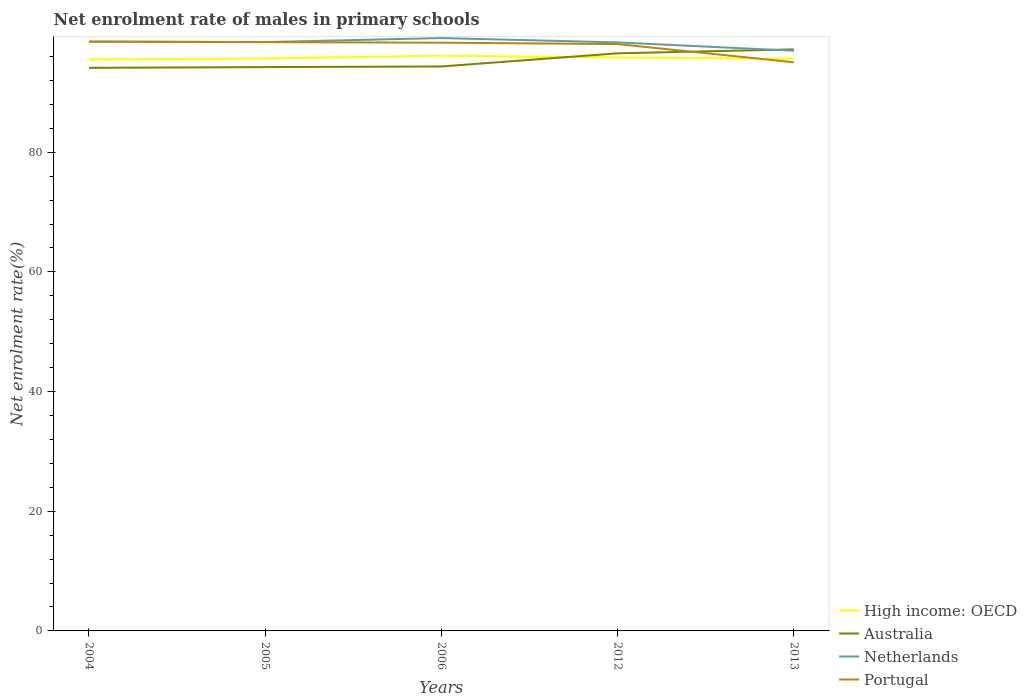How many different coloured lines are there?
Your answer should be very brief. 4. Is the number of lines equal to the number of legend labels?
Your answer should be very brief. Yes. Across all years, what is the maximum net enrolment rate of males in primary schools in High income: OECD?
Make the answer very short. 95.5. In which year was the net enrolment rate of males in primary schools in Australia maximum?
Make the answer very short. 2004. What is the total net enrolment rate of males in primary schools in High income: OECD in the graph?
Offer a terse response. 0.54. What is the difference between the highest and the second highest net enrolment rate of males in primary schools in Portugal?
Keep it short and to the point. 3.47. Is the net enrolment rate of males in primary schools in High income: OECD strictly greater than the net enrolment rate of males in primary schools in Australia over the years?
Give a very brief answer. No. How many years are there in the graph?
Keep it short and to the point. 5. How many legend labels are there?
Your answer should be compact. 4. How are the legend labels stacked?
Give a very brief answer. Vertical. What is the title of the graph?
Offer a very short reply. Net enrolment rate of males in primary schools. What is the label or title of the Y-axis?
Provide a short and direct response. Net enrolment rate(%). What is the Net enrolment rate(%) of High income: OECD in 2004?
Keep it short and to the point. 95.5. What is the Net enrolment rate(%) in Australia in 2004?
Your answer should be very brief. 94.11. What is the Net enrolment rate(%) of Netherlands in 2004?
Provide a succinct answer. 98.47. What is the Net enrolment rate(%) of Portugal in 2004?
Give a very brief answer. 98.51. What is the Net enrolment rate(%) in High income: OECD in 2005?
Ensure brevity in your answer.  95.67. What is the Net enrolment rate(%) in Australia in 2005?
Ensure brevity in your answer.  94.23. What is the Net enrolment rate(%) in Netherlands in 2005?
Ensure brevity in your answer.  98.41. What is the Net enrolment rate(%) of Portugal in 2005?
Offer a very short reply. 98.4. What is the Net enrolment rate(%) of High income: OECD in 2006?
Your response must be concise. 96.13. What is the Net enrolment rate(%) of Australia in 2006?
Offer a terse response. 94.33. What is the Net enrolment rate(%) of Netherlands in 2006?
Make the answer very short. 99.08. What is the Net enrolment rate(%) of Portugal in 2006?
Ensure brevity in your answer.  98.3. What is the Net enrolment rate(%) of High income: OECD in 2012?
Provide a short and direct response. 95.85. What is the Net enrolment rate(%) in Australia in 2012?
Your response must be concise. 96.53. What is the Net enrolment rate(%) in Netherlands in 2012?
Keep it short and to the point. 98.36. What is the Net enrolment rate(%) of Portugal in 2012?
Your answer should be compact. 98.07. What is the Net enrolment rate(%) of High income: OECD in 2013?
Offer a terse response. 95.6. What is the Net enrolment rate(%) of Australia in 2013?
Ensure brevity in your answer.  97.19. What is the Net enrolment rate(%) in Netherlands in 2013?
Your response must be concise. 96.96. What is the Net enrolment rate(%) in Portugal in 2013?
Make the answer very short. 95.03. Across all years, what is the maximum Net enrolment rate(%) of High income: OECD?
Your response must be concise. 96.13. Across all years, what is the maximum Net enrolment rate(%) of Australia?
Your answer should be compact. 97.19. Across all years, what is the maximum Net enrolment rate(%) in Netherlands?
Keep it short and to the point. 99.08. Across all years, what is the maximum Net enrolment rate(%) of Portugal?
Provide a succinct answer. 98.51. Across all years, what is the minimum Net enrolment rate(%) of High income: OECD?
Provide a succinct answer. 95.5. Across all years, what is the minimum Net enrolment rate(%) in Australia?
Give a very brief answer. 94.11. Across all years, what is the minimum Net enrolment rate(%) of Netherlands?
Ensure brevity in your answer.  96.96. Across all years, what is the minimum Net enrolment rate(%) of Portugal?
Your answer should be compact. 95.03. What is the total Net enrolment rate(%) in High income: OECD in the graph?
Make the answer very short. 478.74. What is the total Net enrolment rate(%) in Australia in the graph?
Your response must be concise. 476.39. What is the total Net enrolment rate(%) in Netherlands in the graph?
Make the answer very short. 491.27. What is the total Net enrolment rate(%) of Portugal in the graph?
Offer a terse response. 488.32. What is the difference between the Net enrolment rate(%) in High income: OECD in 2004 and that in 2005?
Your answer should be compact. -0.17. What is the difference between the Net enrolment rate(%) of Australia in 2004 and that in 2005?
Provide a short and direct response. -0.12. What is the difference between the Net enrolment rate(%) in Netherlands in 2004 and that in 2005?
Offer a terse response. 0.06. What is the difference between the Net enrolment rate(%) in Portugal in 2004 and that in 2005?
Provide a short and direct response. 0.11. What is the difference between the Net enrolment rate(%) of High income: OECD in 2004 and that in 2006?
Your response must be concise. -0.63. What is the difference between the Net enrolment rate(%) of Australia in 2004 and that in 2006?
Offer a terse response. -0.23. What is the difference between the Net enrolment rate(%) in Netherlands in 2004 and that in 2006?
Your answer should be very brief. -0.61. What is the difference between the Net enrolment rate(%) of Portugal in 2004 and that in 2006?
Your answer should be very brief. 0.2. What is the difference between the Net enrolment rate(%) in High income: OECD in 2004 and that in 2012?
Your answer should be compact. -0.35. What is the difference between the Net enrolment rate(%) in Australia in 2004 and that in 2012?
Offer a very short reply. -2.42. What is the difference between the Net enrolment rate(%) of Netherlands in 2004 and that in 2012?
Offer a very short reply. 0.11. What is the difference between the Net enrolment rate(%) of Portugal in 2004 and that in 2012?
Make the answer very short. 0.43. What is the difference between the Net enrolment rate(%) of High income: OECD in 2004 and that in 2013?
Your answer should be very brief. -0.1. What is the difference between the Net enrolment rate(%) in Australia in 2004 and that in 2013?
Keep it short and to the point. -3.08. What is the difference between the Net enrolment rate(%) of Netherlands in 2004 and that in 2013?
Provide a short and direct response. 1.51. What is the difference between the Net enrolment rate(%) of Portugal in 2004 and that in 2013?
Ensure brevity in your answer.  3.47. What is the difference between the Net enrolment rate(%) of High income: OECD in 2005 and that in 2006?
Your answer should be very brief. -0.47. What is the difference between the Net enrolment rate(%) in Australia in 2005 and that in 2006?
Keep it short and to the point. -0.1. What is the difference between the Net enrolment rate(%) of Netherlands in 2005 and that in 2006?
Provide a short and direct response. -0.67. What is the difference between the Net enrolment rate(%) of Portugal in 2005 and that in 2006?
Make the answer very short. 0.1. What is the difference between the Net enrolment rate(%) of High income: OECD in 2005 and that in 2012?
Your answer should be very brief. -0.18. What is the difference between the Net enrolment rate(%) of Australia in 2005 and that in 2012?
Your response must be concise. -2.3. What is the difference between the Net enrolment rate(%) in Netherlands in 2005 and that in 2012?
Offer a terse response. 0.05. What is the difference between the Net enrolment rate(%) in Portugal in 2005 and that in 2012?
Ensure brevity in your answer.  0.33. What is the difference between the Net enrolment rate(%) of High income: OECD in 2005 and that in 2013?
Provide a succinct answer. 0.07. What is the difference between the Net enrolment rate(%) in Australia in 2005 and that in 2013?
Offer a very short reply. -2.96. What is the difference between the Net enrolment rate(%) in Netherlands in 2005 and that in 2013?
Keep it short and to the point. 1.45. What is the difference between the Net enrolment rate(%) in Portugal in 2005 and that in 2013?
Your response must be concise. 3.37. What is the difference between the Net enrolment rate(%) in High income: OECD in 2006 and that in 2012?
Your answer should be very brief. 0.29. What is the difference between the Net enrolment rate(%) in Australia in 2006 and that in 2012?
Your response must be concise. -2.2. What is the difference between the Net enrolment rate(%) of Netherlands in 2006 and that in 2012?
Provide a short and direct response. 0.72. What is the difference between the Net enrolment rate(%) in Portugal in 2006 and that in 2012?
Offer a terse response. 0.23. What is the difference between the Net enrolment rate(%) of High income: OECD in 2006 and that in 2013?
Offer a very short reply. 0.54. What is the difference between the Net enrolment rate(%) of Australia in 2006 and that in 2013?
Your answer should be compact. -2.85. What is the difference between the Net enrolment rate(%) of Netherlands in 2006 and that in 2013?
Provide a short and direct response. 2.12. What is the difference between the Net enrolment rate(%) in Portugal in 2006 and that in 2013?
Offer a very short reply. 3.27. What is the difference between the Net enrolment rate(%) in High income: OECD in 2012 and that in 2013?
Provide a short and direct response. 0.25. What is the difference between the Net enrolment rate(%) of Australia in 2012 and that in 2013?
Keep it short and to the point. -0.66. What is the difference between the Net enrolment rate(%) in Netherlands in 2012 and that in 2013?
Provide a short and direct response. 1.4. What is the difference between the Net enrolment rate(%) in Portugal in 2012 and that in 2013?
Your answer should be very brief. 3.04. What is the difference between the Net enrolment rate(%) in High income: OECD in 2004 and the Net enrolment rate(%) in Australia in 2005?
Offer a very short reply. 1.27. What is the difference between the Net enrolment rate(%) in High income: OECD in 2004 and the Net enrolment rate(%) in Netherlands in 2005?
Offer a very short reply. -2.91. What is the difference between the Net enrolment rate(%) in High income: OECD in 2004 and the Net enrolment rate(%) in Portugal in 2005?
Your answer should be compact. -2.9. What is the difference between the Net enrolment rate(%) in Australia in 2004 and the Net enrolment rate(%) in Netherlands in 2005?
Your answer should be very brief. -4.3. What is the difference between the Net enrolment rate(%) in Australia in 2004 and the Net enrolment rate(%) in Portugal in 2005?
Offer a very short reply. -4.29. What is the difference between the Net enrolment rate(%) in Netherlands in 2004 and the Net enrolment rate(%) in Portugal in 2005?
Your response must be concise. 0.07. What is the difference between the Net enrolment rate(%) of High income: OECD in 2004 and the Net enrolment rate(%) of Australia in 2006?
Give a very brief answer. 1.16. What is the difference between the Net enrolment rate(%) in High income: OECD in 2004 and the Net enrolment rate(%) in Netherlands in 2006?
Offer a very short reply. -3.58. What is the difference between the Net enrolment rate(%) of High income: OECD in 2004 and the Net enrolment rate(%) of Portugal in 2006?
Offer a very short reply. -2.8. What is the difference between the Net enrolment rate(%) of Australia in 2004 and the Net enrolment rate(%) of Netherlands in 2006?
Keep it short and to the point. -4.97. What is the difference between the Net enrolment rate(%) of Australia in 2004 and the Net enrolment rate(%) of Portugal in 2006?
Your response must be concise. -4.2. What is the difference between the Net enrolment rate(%) of Netherlands in 2004 and the Net enrolment rate(%) of Portugal in 2006?
Your response must be concise. 0.17. What is the difference between the Net enrolment rate(%) in High income: OECD in 2004 and the Net enrolment rate(%) in Australia in 2012?
Keep it short and to the point. -1.03. What is the difference between the Net enrolment rate(%) in High income: OECD in 2004 and the Net enrolment rate(%) in Netherlands in 2012?
Offer a terse response. -2.86. What is the difference between the Net enrolment rate(%) in High income: OECD in 2004 and the Net enrolment rate(%) in Portugal in 2012?
Your response must be concise. -2.58. What is the difference between the Net enrolment rate(%) in Australia in 2004 and the Net enrolment rate(%) in Netherlands in 2012?
Ensure brevity in your answer.  -4.25. What is the difference between the Net enrolment rate(%) of Australia in 2004 and the Net enrolment rate(%) of Portugal in 2012?
Your answer should be compact. -3.97. What is the difference between the Net enrolment rate(%) in Netherlands in 2004 and the Net enrolment rate(%) in Portugal in 2012?
Offer a very short reply. 0.4. What is the difference between the Net enrolment rate(%) of High income: OECD in 2004 and the Net enrolment rate(%) of Australia in 2013?
Your answer should be compact. -1.69. What is the difference between the Net enrolment rate(%) of High income: OECD in 2004 and the Net enrolment rate(%) of Netherlands in 2013?
Give a very brief answer. -1.46. What is the difference between the Net enrolment rate(%) of High income: OECD in 2004 and the Net enrolment rate(%) of Portugal in 2013?
Keep it short and to the point. 0.47. What is the difference between the Net enrolment rate(%) in Australia in 2004 and the Net enrolment rate(%) in Netherlands in 2013?
Give a very brief answer. -2.85. What is the difference between the Net enrolment rate(%) of Australia in 2004 and the Net enrolment rate(%) of Portugal in 2013?
Provide a succinct answer. -0.92. What is the difference between the Net enrolment rate(%) in Netherlands in 2004 and the Net enrolment rate(%) in Portugal in 2013?
Offer a terse response. 3.44. What is the difference between the Net enrolment rate(%) of High income: OECD in 2005 and the Net enrolment rate(%) of Australia in 2006?
Provide a short and direct response. 1.33. What is the difference between the Net enrolment rate(%) in High income: OECD in 2005 and the Net enrolment rate(%) in Netherlands in 2006?
Give a very brief answer. -3.41. What is the difference between the Net enrolment rate(%) of High income: OECD in 2005 and the Net enrolment rate(%) of Portugal in 2006?
Keep it short and to the point. -2.64. What is the difference between the Net enrolment rate(%) in Australia in 2005 and the Net enrolment rate(%) in Netherlands in 2006?
Give a very brief answer. -4.85. What is the difference between the Net enrolment rate(%) in Australia in 2005 and the Net enrolment rate(%) in Portugal in 2006?
Offer a very short reply. -4.07. What is the difference between the Net enrolment rate(%) in Netherlands in 2005 and the Net enrolment rate(%) in Portugal in 2006?
Your answer should be compact. 0.11. What is the difference between the Net enrolment rate(%) of High income: OECD in 2005 and the Net enrolment rate(%) of Australia in 2012?
Provide a succinct answer. -0.87. What is the difference between the Net enrolment rate(%) in High income: OECD in 2005 and the Net enrolment rate(%) in Netherlands in 2012?
Provide a succinct answer. -2.69. What is the difference between the Net enrolment rate(%) of High income: OECD in 2005 and the Net enrolment rate(%) of Portugal in 2012?
Provide a succinct answer. -2.41. What is the difference between the Net enrolment rate(%) of Australia in 2005 and the Net enrolment rate(%) of Netherlands in 2012?
Offer a very short reply. -4.13. What is the difference between the Net enrolment rate(%) of Australia in 2005 and the Net enrolment rate(%) of Portugal in 2012?
Make the answer very short. -3.84. What is the difference between the Net enrolment rate(%) in Netherlands in 2005 and the Net enrolment rate(%) in Portugal in 2012?
Your answer should be compact. 0.33. What is the difference between the Net enrolment rate(%) in High income: OECD in 2005 and the Net enrolment rate(%) in Australia in 2013?
Your response must be concise. -1.52. What is the difference between the Net enrolment rate(%) of High income: OECD in 2005 and the Net enrolment rate(%) of Netherlands in 2013?
Your response must be concise. -1.29. What is the difference between the Net enrolment rate(%) of High income: OECD in 2005 and the Net enrolment rate(%) of Portugal in 2013?
Offer a terse response. 0.63. What is the difference between the Net enrolment rate(%) in Australia in 2005 and the Net enrolment rate(%) in Netherlands in 2013?
Keep it short and to the point. -2.73. What is the difference between the Net enrolment rate(%) of Australia in 2005 and the Net enrolment rate(%) of Portugal in 2013?
Keep it short and to the point. -0.8. What is the difference between the Net enrolment rate(%) of Netherlands in 2005 and the Net enrolment rate(%) of Portugal in 2013?
Give a very brief answer. 3.38. What is the difference between the Net enrolment rate(%) of High income: OECD in 2006 and the Net enrolment rate(%) of Australia in 2012?
Ensure brevity in your answer.  -0.4. What is the difference between the Net enrolment rate(%) in High income: OECD in 2006 and the Net enrolment rate(%) in Netherlands in 2012?
Provide a short and direct response. -2.22. What is the difference between the Net enrolment rate(%) of High income: OECD in 2006 and the Net enrolment rate(%) of Portugal in 2012?
Offer a terse response. -1.94. What is the difference between the Net enrolment rate(%) of Australia in 2006 and the Net enrolment rate(%) of Netherlands in 2012?
Keep it short and to the point. -4.02. What is the difference between the Net enrolment rate(%) of Australia in 2006 and the Net enrolment rate(%) of Portugal in 2012?
Your response must be concise. -3.74. What is the difference between the Net enrolment rate(%) in Netherlands in 2006 and the Net enrolment rate(%) in Portugal in 2012?
Keep it short and to the point. 1.01. What is the difference between the Net enrolment rate(%) of High income: OECD in 2006 and the Net enrolment rate(%) of Australia in 2013?
Provide a short and direct response. -1.06. What is the difference between the Net enrolment rate(%) of High income: OECD in 2006 and the Net enrolment rate(%) of Netherlands in 2013?
Provide a succinct answer. -0.83. What is the difference between the Net enrolment rate(%) of High income: OECD in 2006 and the Net enrolment rate(%) of Portugal in 2013?
Give a very brief answer. 1.1. What is the difference between the Net enrolment rate(%) in Australia in 2006 and the Net enrolment rate(%) in Netherlands in 2013?
Ensure brevity in your answer.  -2.62. What is the difference between the Net enrolment rate(%) in Australia in 2006 and the Net enrolment rate(%) in Portugal in 2013?
Provide a short and direct response. -0.7. What is the difference between the Net enrolment rate(%) in Netherlands in 2006 and the Net enrolment rate(%) in Portugal in 2013?
Offer a terse response. 4.05. What is the difference between the Net enrolment rate(%) in High income: OECD in 2012 and the Net enrolment rate(%) in Australia in 2013?
Make the answer very short. -1.34. What is the difference between the Net enrolment rate(%) in High income: OECD in 2012 and the Net enrolment rate(%) in Netherlands in 2013?
Offer a terse response. -1.11. What is the difference between the Net enrolment rate(%) in High income: OECD in 2012 and the Net enrolment rate(%) in Portugal in 2013?
Your response must be concise. 0.81. What is the difference between the Net enrolment rate(%) in Australia in 2012 and the Net enrolment rate(%) in Netherlands in 2013?
Your answer should be compact. -0.43. What is the difference between the Net enrolment rate(%) of Australia in 2012 and the Net enrolment rate(%) of Portugal in 2013?
Offer a terse response. 1.5. What is the difference between the Net enrolment rate(%) in Netherlands in 2012 and the Net enrolment rate(%) in Portugal in 2013?
Make the answer very short. 3.32. What is the average Net enrolment rate(%) in High income: OECD per year?
Provide a succinct answer. 95.75. What is the average Net enrolment rate(%) of Australia per year?
Your response must be concise. 95.28. What is the average Net enrolment rate(%) of Netherlands per year?
Your answer should be very brief. 98.25. What is the average Net enrolment rate(%) of Portugal per year?
Ensure brevity in your answer.  97.66. In the year 2004, what is the difference between the Net enrolment rate(%) in High income: OECD and Net enrolment rate(%) in Australia?
Your response must be concise. 1.39. In the year 2004, what is the difference between the Net enrolment rate(%) of High income: OECD and Net enrolment rate(%) of Netherlands?
Your answer should be compact. -2.97. In the year 2004, what is the difference between the Net enrolment rate(%) in High income: OECD and Net enrolment rate(%) in Portugal?
Offer a terse response. -3.01. In the year 2004, what is the difference between the Net enrolment rate(%) of Australia and Net enrolment rate(%) of Netherlands?
Your response must be concise. -4.36. In the year 2004, what is the difference between the Net enrolment rate(%) of Australia and Net enrolment rate(%) of Portugal?
Your answer should be very brief. -4.4. In the year 2004, what is the difference between the Net enrolment rate(%) of Netherlands and Net enrolment rate(%) of Portugal?
Keep it short and to the point. -0.04. In the year 2005, what is the difference between the Net enrolment rate(%) in High income: OECD and Net enrolment rate(%) in Australia?
Your answer should be compact. 1.44. In the year 2005, what is the difference between the Net enrolment rate(%) of High income: OECD and Net enrolment rate(%) of Netherlands?
Give a very brief answer. -2.74. In the year 2005, what is the difference between the Net enrolment rate(%) of High income: OECD and Net enrolment rate(%) of Portugal?
Your response must be concise. -2.74. In the year 2005, what is the difference between the Net enrolment rate(%) in Australia and Net enrolment rate(%) in Netherlands?
Your response must be concise. -4.18. In the year 2005, what is the difference between the Net enrolment rate(%) of Australia and Net enrolment rate(%) of Portugal?
Offer a terse response. -4.17. In the year 2005, what is the difference between the Net enrolment rate(%) in Netherlands and Net enrolment rate(%) in Portugal?
Offer a terse response. 0.01. In the year 2006, what is the difference between the Net enrolment rate(%) in High income: OECD and Net enrolment rate(%) in Australia?
Your response must be concise. 1.8. In the year 2006, what is the difference between the Net enrolment rate(%) of High income: OECD and Net enrolment rate(%) of Netherlands?
Your answer should be compact. -2.95. In the year 2006, what is the difference between the Net enrolment rate(%) in High income: OECD and Net enrolment rate(%) in Portugal?
Offer a terse response. -2.17. In the year 2006, what is the difference between the Net enrolment rate(%) in Australia and Net enrolment rate(%) in Netherlands?
Provide a succinct answer. -4.75. In the year 2006, what is the difference between the Net enrolment rate(%) of Australia and Net enrolment rate(%) of Portugal?
Your answer should be very brief. -3.97. In the year 2006, what is the difference between the Net enrolment rate(%) in Netherlands and Net enrolment rate(%) in Portugal?
Ensure brevity in your answer.  0.78. In the year 2012, what is the difference between the Net enrolment rate(%) in High income: OECD and Net enrolment rate(%) in Australia?
Make the answer very short. -0.69. In the year 2012, what is the difference between the Net enrolment rate(%) in High income: OECD and Net enrolment rate(%) in Netherlands?
Your response must be concise. -2.51. In the year 2012, what is the difference between the Net enrolment rate(%) of High income: OECD and Net enrolment rate(%) of Portugal?
Keep it short and to the point. -2.23. In the year 2012, what is the difference between the Net enrolment rate(%) of Australia and Net enrolment rate(%) of Netherlands?
Your answer should be compact. -1.82. In the year 2012, what is the difference between the Net enrolment rate(%) in Australia and Net enrolment rate(%) in Portugal?
Provide a short and direct response. -1.54. In the year 2012, what is the difference between the Net enrolment rate(%) in Netherlands and Net enrolment rate(%) in Portugal?
Make the answer very short. 0.28. In the year 2013, what is the difference between the Net enrolment rate(%) of High income: OECD and Net enrolment rate(%) of Australia?
Provide a succinct answer. -1.59. In the year 2013, what is the difference between the Net enrolment rate(%) in High income: OECD and Net enrolment rate(%) in Netherlands?
Keep it short and to the point. -1.36. In the year 2013, what is the difference between the Net enrolment rate(%) of High income: OECD and Net enrolment rate(%) of Portugal?
Offer a very short reply. 0.56. In the year 2013, what is the difference between the Net enrolment rate(%) of Australia and Net enrolment rate(%) of Netherlands?
Give a very brief answer. 0.23. In the year 2013, what is the difference between the Net enrolment rate(%) in Australia and Net enrolment rate(%) in Portugal?
Provide a short and direct response. 2.16. In the year 2013, what is the difference between the Net enrolment rate(%) in Netherlands and Net enrolment rate(%) in Portugal?
Provide a short and direct response. 1.93. What is the ratio of the Net enrolment rate(%) of Netherlands in 2004 to that in 2005?
Make the answer very short. 1. What is the ratio of the Net enrolment rate(%) of Portugal in 2004 to that in 2005?
Keep it short and to the point. 1. What is the ratio of the Net enrolment rate(%) of Portugal in 2004 to that in 2006?
Provide a succinct answer. 1. What is the ratio of the Net enrolment rate(%) of High income: OECD in 2004 to that in 2012?
Offer a terse response. 1. What is the ratio of the Net enrolment rate(%) in Australia in 2004 to that in 2012?
Provide a succinct answer. 0.97. What is the ratio of the Net enrolment rate(%) in High income: OECD in 2004 to that in 2013?
Your answer should be very brief. 1. What is the ratio of the Net enrolment rate(%) of Australia in 2004 to that in 2013?
Your answer should be very brief. 0.97. What is the ratio of the Net enrolment rate(%) in Netherlands in 2004 to that in 2013?
Offer a very short reply. 1.02. What is the ratio of the Net enrolment rate(%) of Portugal in 2004 to that in 2013?
Keep it short and to the point. 1.04. What is the ratio of the Net enrolment rate(%) of High income: OECD in 2005 to that in 2012?
Offer a terse response. 1. What is the ratio of the Net enrolment rate(%) of Australia in 2005 to that in 2012?
Your answer should be very brief. 0.98. What is the ratio of the Net enrolment rate(%) in Netherlands in 2005 to that in 2012?
Offer a very short reply. 1. What is the ratio of the Net enrolment rate(%) of Australia in 2005 to that in 2013?
Provide a short and direct response. 0.97. What is the ratio of the Net enrolment rate(%) in Netherlands in 2005 to that in 2013?
Provide a short and direct response. 1.01. What is the ratio of the Net enrolment rate(%) in Portugal in 2005 to that in 2013?
Your answer should be compact. 1.04. What is the ratio of the Net enrolment rate(%) in High income: OECD in 2006 to that in 2012?
Give a very brief answer. 1. What is the ratio of the Net enrolment rate(%) in Australia in 2006 to that in 2012?
Your response must be concise. 0.98. What is the ratio of the Net enrolment rate(%) of Netherlands in 2006 to that in 2012?
Keep it short and to the point. 1.01. What is the ratio of the Net enrolment rate(%) of Portugal in 2006 to that in 2012?
Provide a short and direct response. 1. What is the ratio of the Net enrolment rate(%) of High income: OECD in 2006 to that in 2013?
Ensure brevity in your answer.  1.01. What is the ratio of the Net enrolment rate(%) of Australia in 2006 to that in 2013?
Offer a terse response. 0.97. What is the ratio of the Net enrolment rate(%) of Netherlands in 2006 to that in 2013?
Make the answer very short. 1.02. What is the ratio of the Net enrolment rate(%) of Portugal in 2006 to that in 2013?
Provide a short and direct response. 1.03. What is the ratio of the Net enrolment rate(%) in High income: OECD in 2012 to that in 2013?
Offer a terse response. 1. What is the ratio of the Net enrolment rate(%) of Australia in 2012 to that in 2013?
Keep it short and to the point. 0.99. What is the ratio of the Net enrolment rate(%) in Netherlands in 2012 to that in 2013?
Offer a very short reply. 1.01. What is the ratio of the Net enrolment rate(%) in Portugal in 2012 to that in 2013?
Provide a succinct answer. 1.03. What is the difference between the highest and the second highest Net enrolment rate(%) in High income: OECD?
Make the answer very short. 0.29. What is the difference between the highest and the second highest Net enrolment rate(%) of Australia?
Give a very brief answer. 0.66. What is the difference between the highest and the second highest Net enrolment rate(%) of Netherlands?
Provide a succinct answer. 0.61. What is the difference between the highest and the second highest Net enrolment rate(%) of Portugal?
Keep it short and to the point. 0.11. What is the difference between the highest and the lowest Net enrolment rate(%) of High income: OECD?
Make the answer very short. 0.63. What is the difference between the highest and the lowest Net enrolment rate(%) of Australia?
Give a very brief answer. 3.08. What is the difference between the highest and the lowest Net enrolment rate(%) of Netherlands?
Provide a succinct answer. 2.12. What is the difference between the highest and the lowest Net enrolment rate(%) in Portugal?
Your response must be concise. 3.47. 